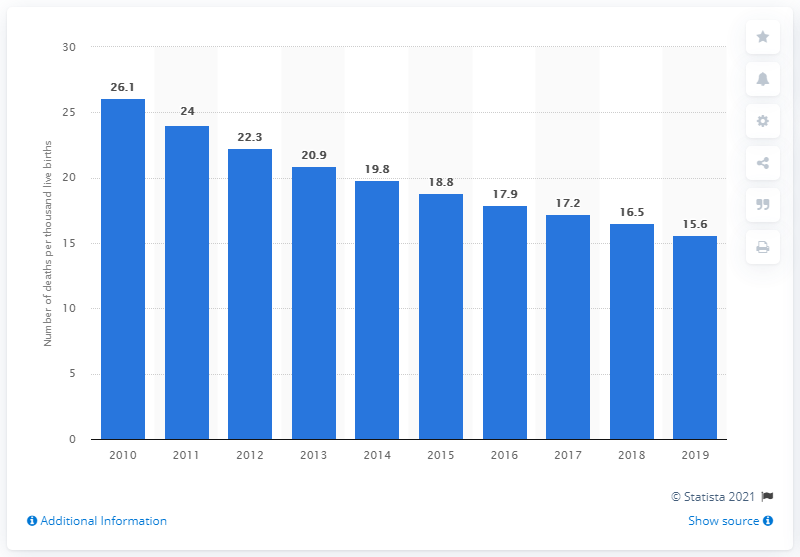Draw attention to some important aspects in this diagram. The sum of 2015 and 2016 is 36.7... The maximum number of live births is 26.1. In 2019, the under-five child mortality rate in Mongolia was 15.6 deaths per 1,000 live births. 